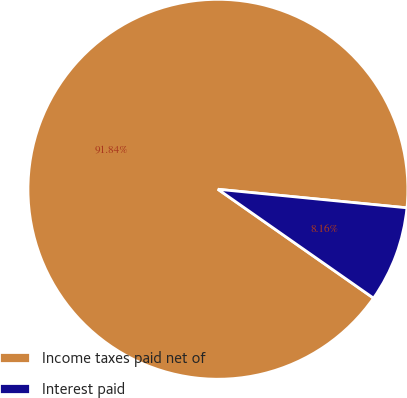Convert chart. <chart><loc_0><loc_0><loc_500><loc_500><pie_chart><fcel>Income taxes paid net of<fcel>Interest paid<nl><fcel>91.84%<fcel>8.16%<nl></chart> 